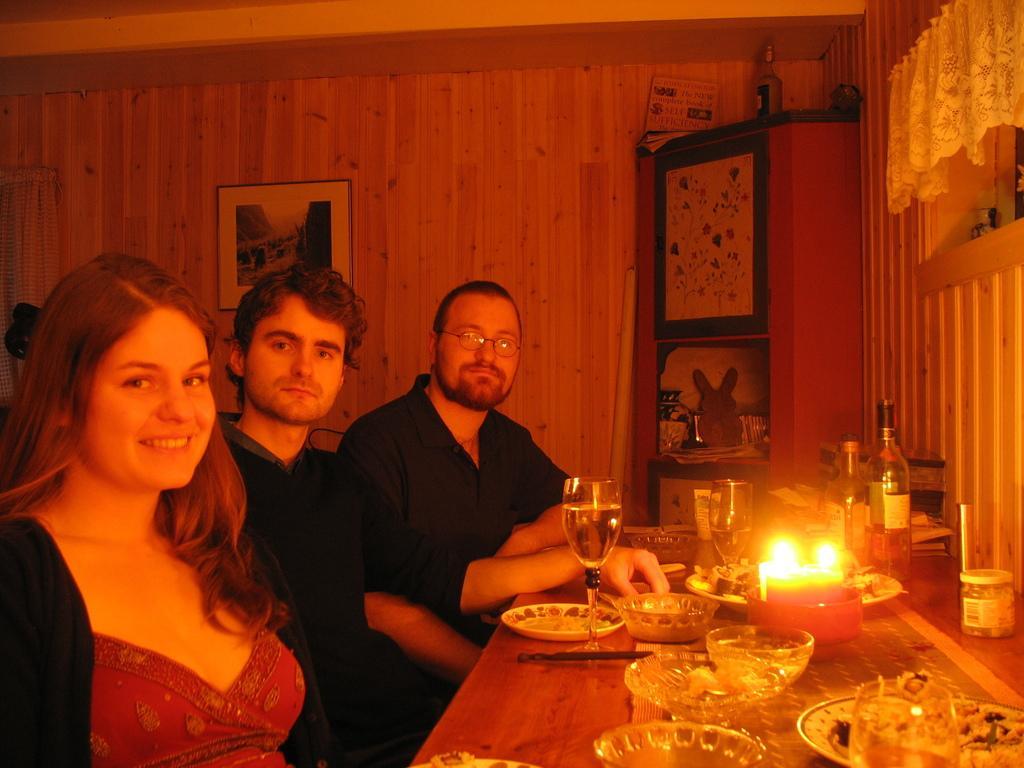Could you give a brief overview of what you see in this image? In this image there are three person sitting on the chair. On the table there is a plate,bowl,glass,candle and a bottle. The frame is attached to the wooden wall. 